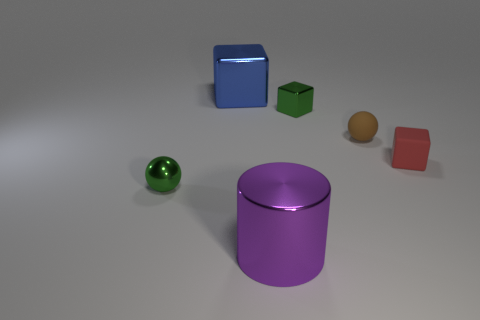How many large things are cyan metallic cubes or cubes?
Provide a succinct answer. 1. There is a green metallic object that is the same shape as the red object; what is its size?
Your answer should be compact. Small. Is there anything else that is the same size as the green sphere?
Offer a terse response. Yes. What material is the large object on the right side of the metal block that is on the left side of the purple metal thing made of?
Provide a succinct answer. Metal. How many metal objects are purple blocks or green cubes?
Your answer should be compact. 1. What is the color of the matte object that is the same shape as the blue metallic thing?
Your answer should be very brief. Red. What number of small blocks have the same color as the small metal ball?
Make the answer very short. 1. There is a small green object that is behind the small red thing; is there a green ball that is behind it?
Keep it short and to the point. No. How many things are in front of the tiny metallic block and behind the red cube?
Ensure brevity in your answer.  1. How many tiny green cubes have the same material as the brown object?
Your response must be concise. 0. 